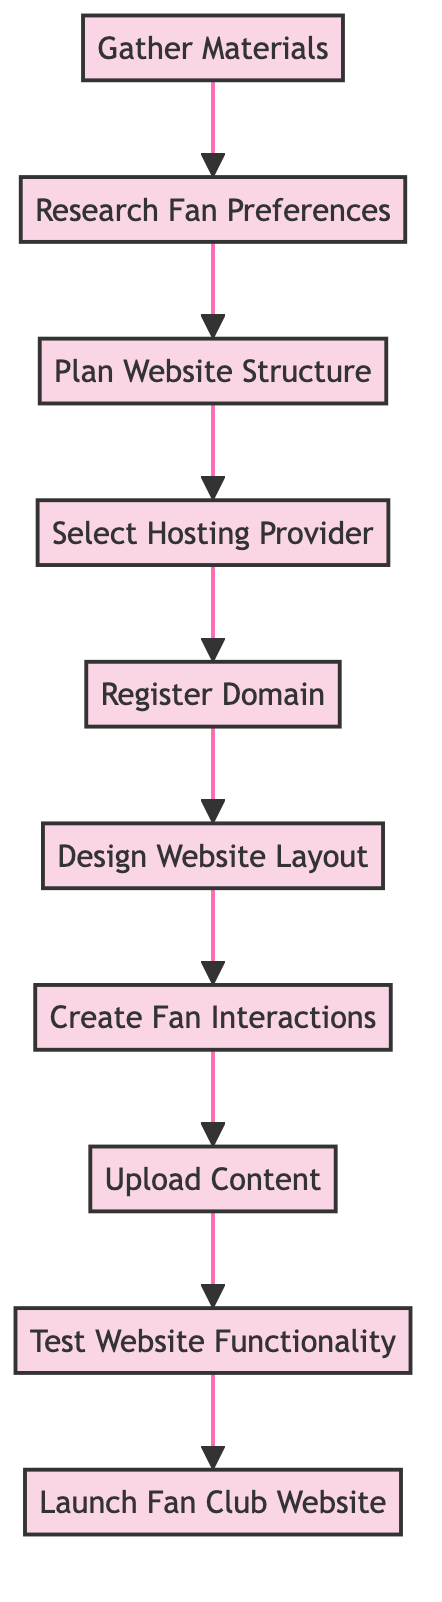What is the final step in creating the fan club website? The diagram indicates that the last node, at the top, is "Launch Fan Club Website", representing the final step in the process.
Answer: Launch Fan Club Website How many steps are involved in the process? By counting the nodes in the diagram from "Gather Materials" to "Launch Fan Club Website", there are a total of 10 steps illustrated.
Answer: 10 What comes before "Upload Content"? According to the flow, the step right before "Upload Content" is "Create Fan Interactions", indicating the sequence of operations.
Answer: Create Fan Interactions Which step directly follows "Test Website Functionality"? The diagram shows that "Launch Fan Club Website" is the step that follows "Test Website Functionality", providing a clear sequence in the process.
Answer: Launch Fan Club Website What is the first step in the diagram? The first step shown in the flow chart is "Gather Materials", which serves as the starting point of the instructions.
Answer: Gather Materials What type of user engagement methods are planned in the fan club website? The step labeled "Create Fan Interactions" specifies that forums, chat rooms, and interactive polls are part of the planned user engagement methods.
Answer: Forums, chat rooms, and interactive polls What is required before selecting a hosting provider? The diagram indicates that "Register Domain" must be completed before the "Select Hosting Provider" step, establishing a necessary order.
Answer: Register Domain What is the purpose of the "Research Fan Preferences" step? This step aims to gather insights into what content and features fans want, indicating it serves a critical role in shaping the website based on user desires.
Answer: Gather insights into fan content and features preferences 